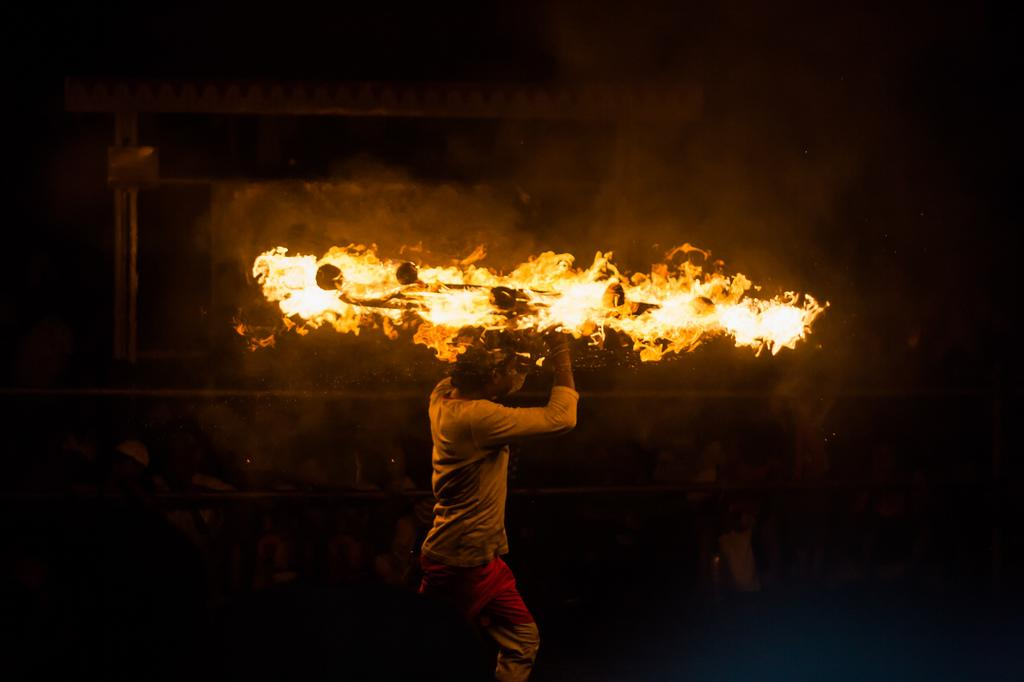What is the main subject of the image? The main subject of the image is a person walking. What is the person holding in the image? The person is holding a stand with fire. What can be seen in the background of the image? There is an arch in the background of the image. What is the laborer's purpose in the image? There is no laborer mentioned in the image, only a person walking with a stand of fire. Is there a donkey present in the image? No, there is no donkey present in the image. 